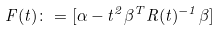Convert formula to latex. <formula><loc_0><loc_0><loc_500><loc_500>F ( t ) \colon = [ \alpha - t ^ { 2 } \beta ^ { T } R ( t ) ^ { - 1 } \beta ]</formula> 